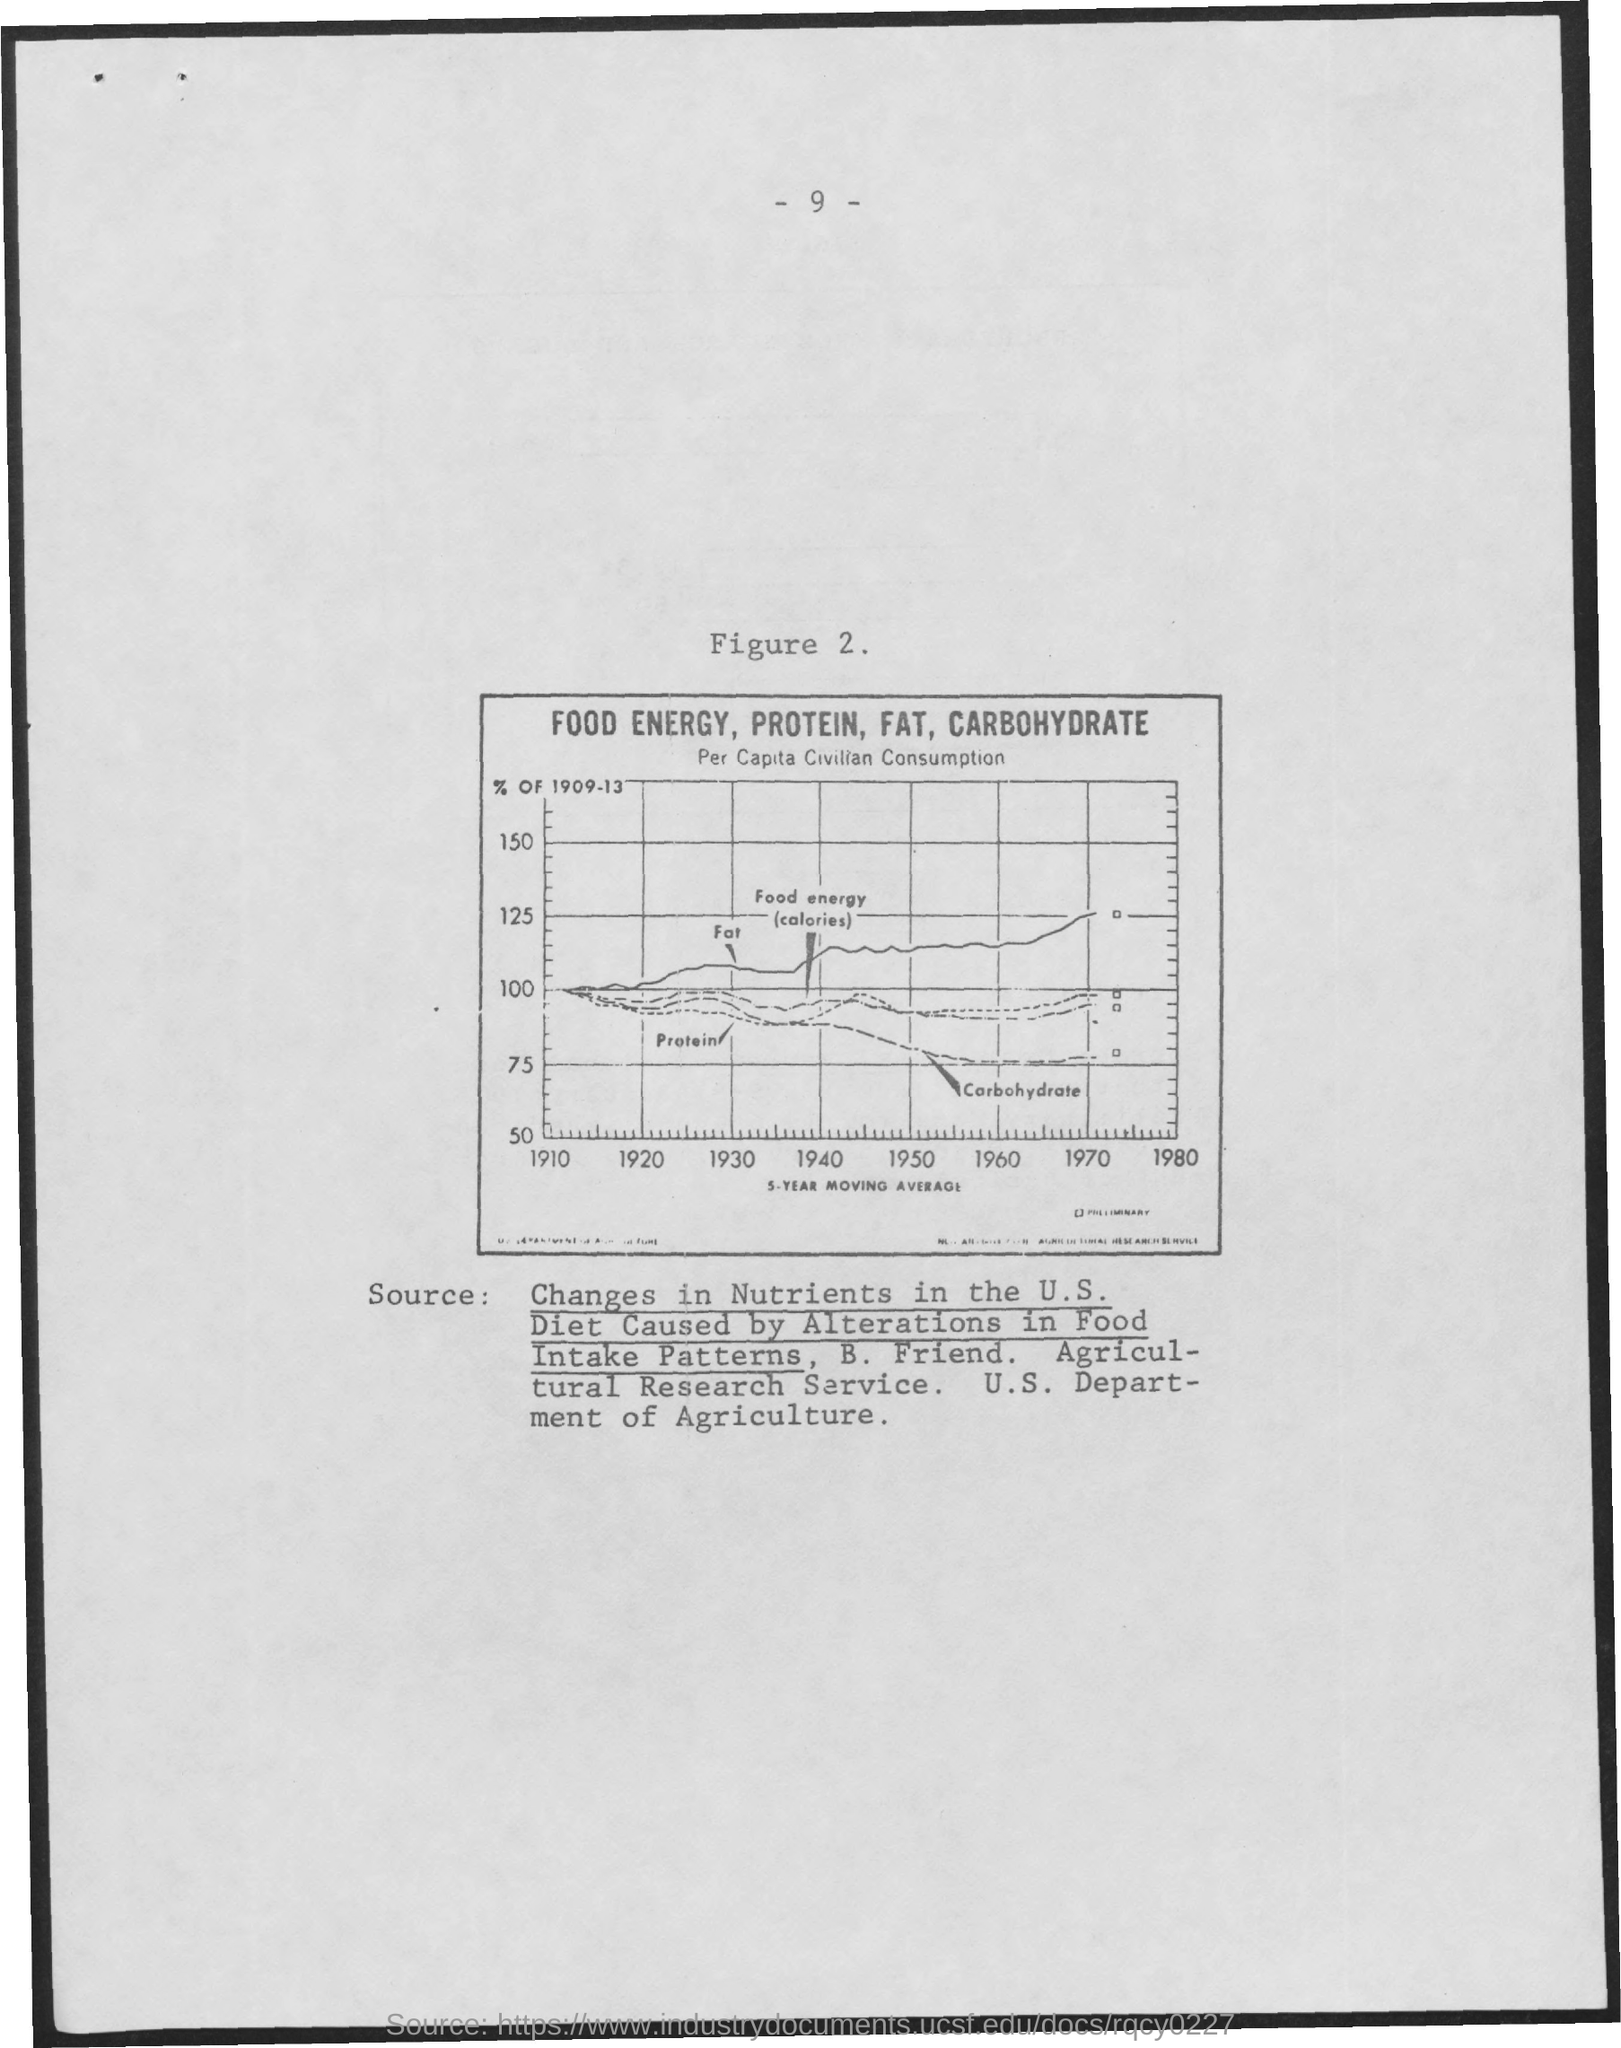Highlight a few significant elements in this photo. The page number is 9, with... The title of the first item inside the box is 'Food Energy, Protein, Fat, Carbohydrate..' The second title inside the box is 'per capita civilian consumption,' which refers to the amount of electricity consumed by each individual in a civilian setting. 